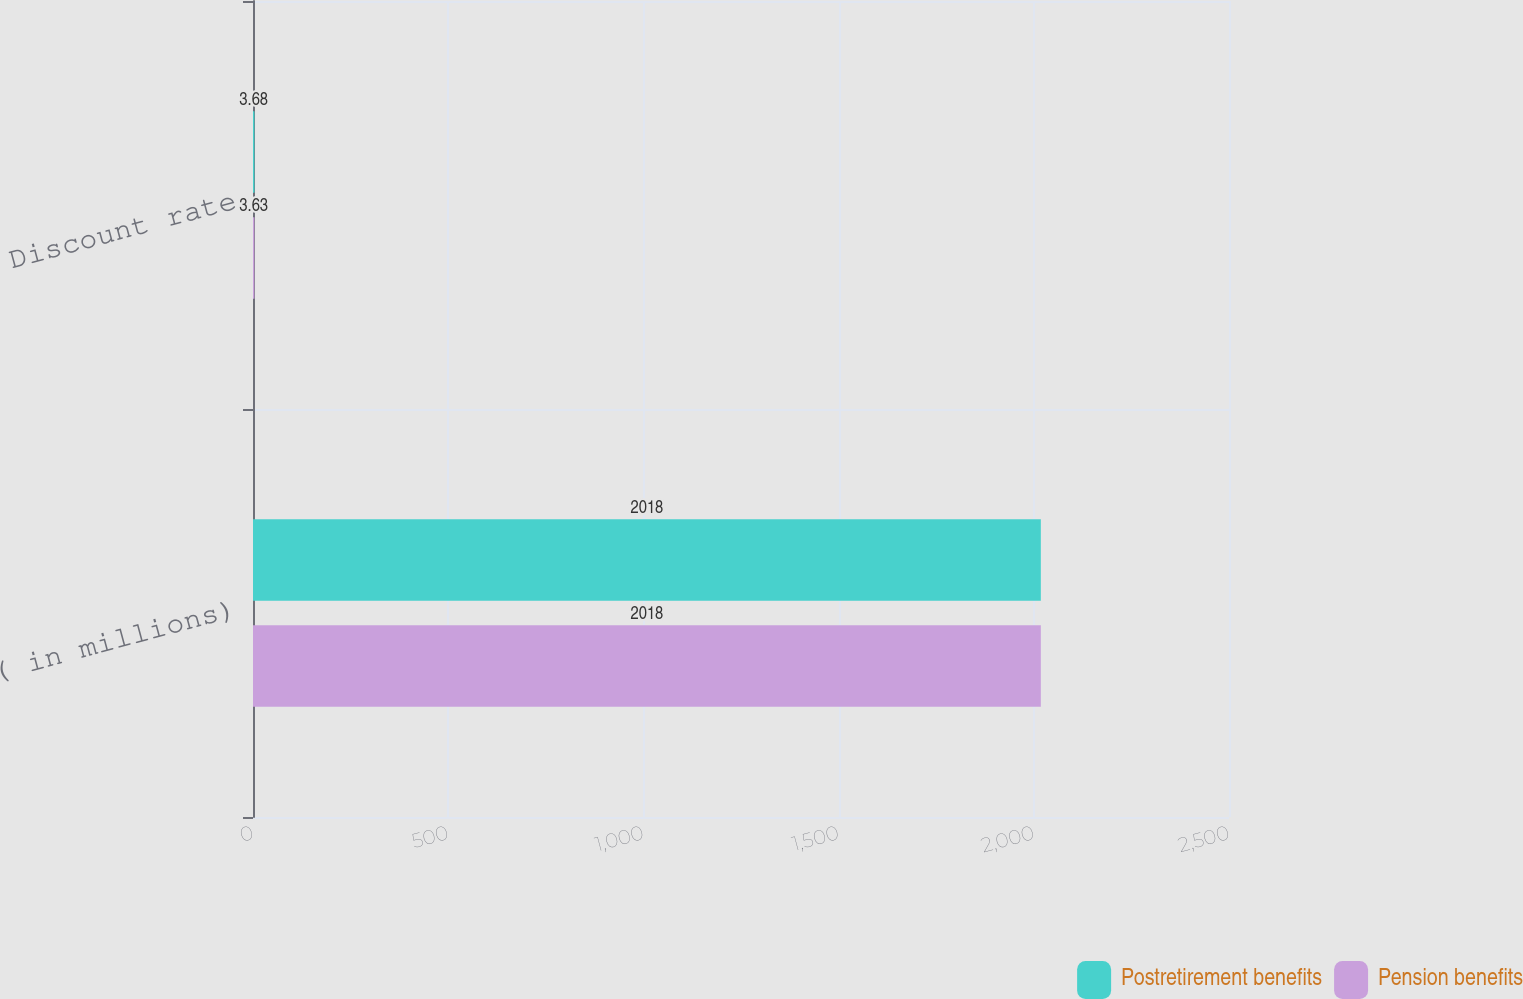Convert chart to OTSL. <chart><loc_0><loc_0><loc_500><loc_500><stacked_bar_chart><ecel><fcel>( in millions)<fcel>Discount rate<nl><fcel>Postretirement benefits<fcel>2018<fcel>3.68<nl><fcel>Pension benefits<fcel>2018<fcel>3.63<nl></chart> 